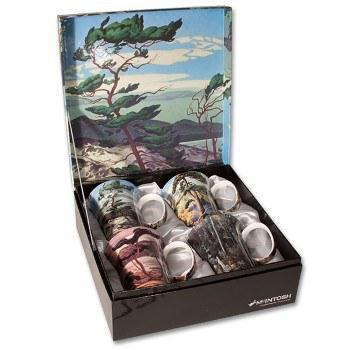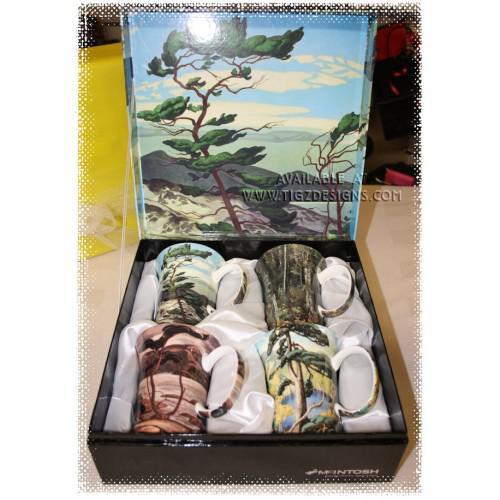The first image is the image on the left, the second image is the image on the right. Examine the images to the left and right. Is the description "Four mugs sit in a case while four sit outside the case in the image on the right." accurate? Answer yes or no. No. 